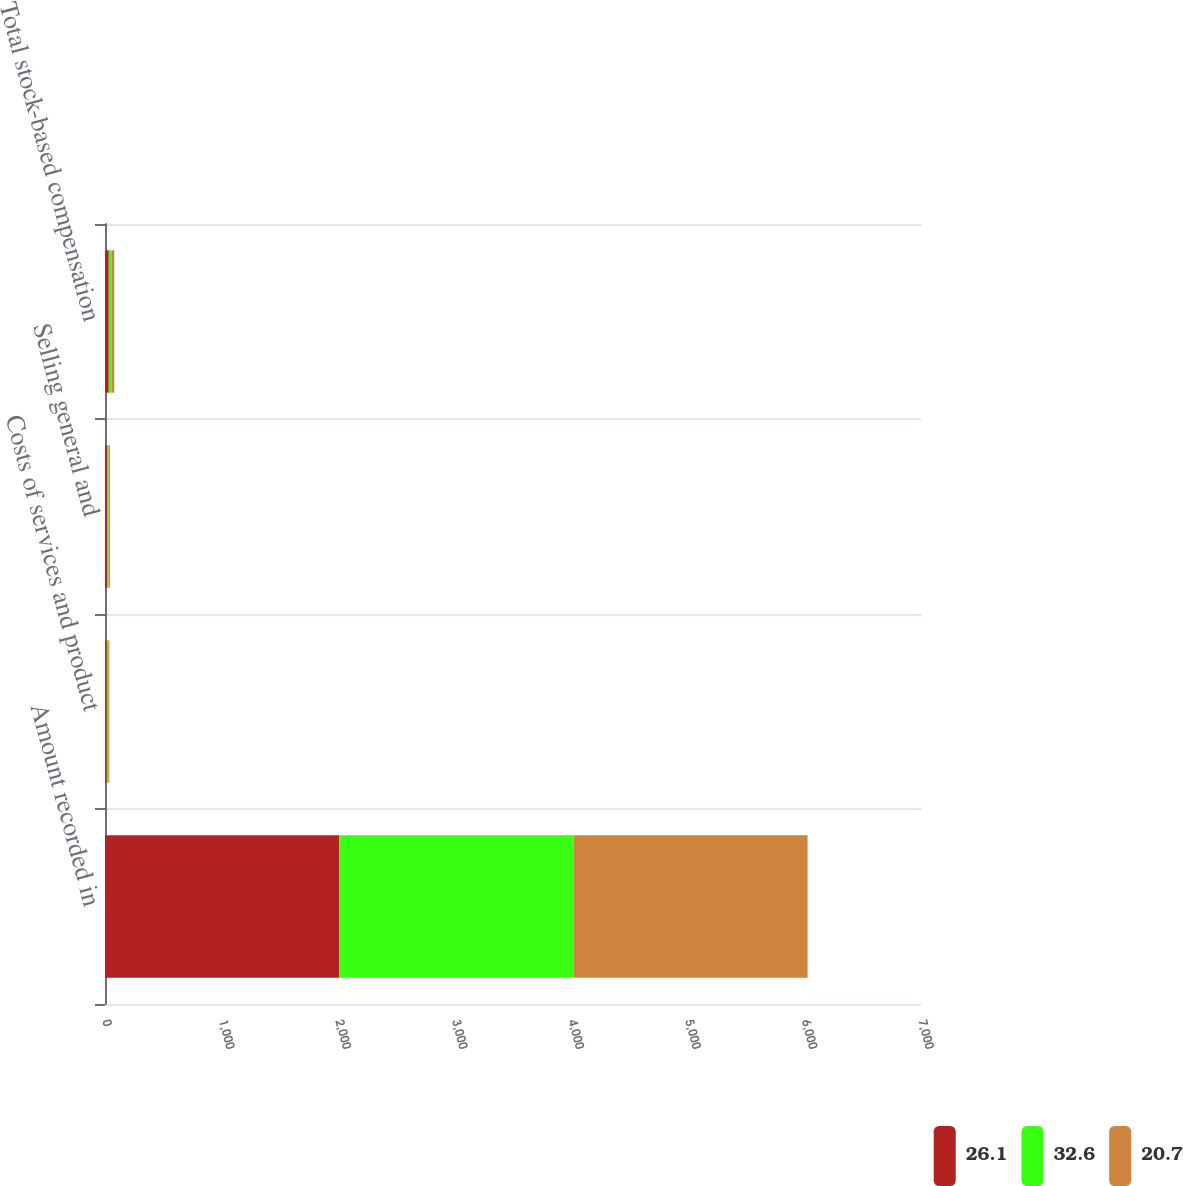Convert chart. <chart><loc_0><loc_0><loc_500><loc_500><stacked_bar_chart><ecel><fcel>Amount recorded in<fcel>Costs of services and product<fcel>Selling general and<fcel>Total stock-based compensation<nl><fcel>26.1<fcel>2010<fcel>14.8<fcel>17.8<fcel>32.6<nl><fcel>32.6<fcel>2009<fcel>12.6<fcel>13.5<fcel>26.1<nl><fcel>20.7<fcel>2008<fcel>9.6<fcel>11.1<fcel>20.7<nl></chart> 